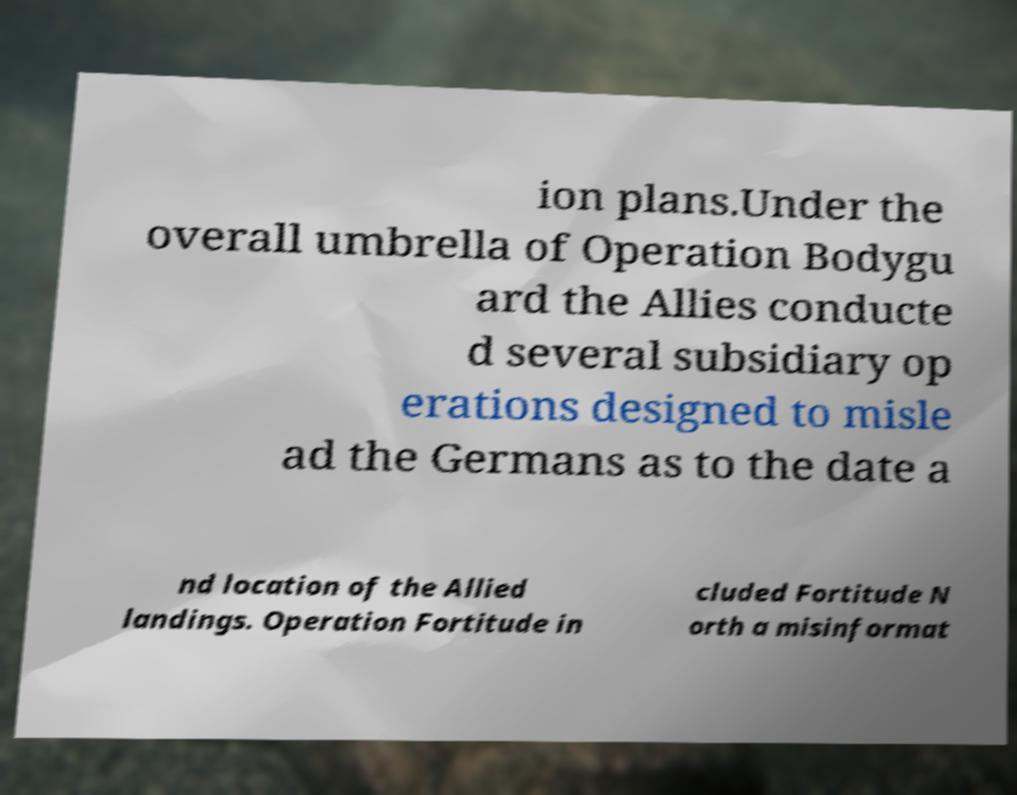Can you accurately transcribe the text from the provided image for me? ion plans.Under the overall umbrella of Operation Bodygu ard the Allies conducte d several subsidiary op erations designed to misle ad the Germans as to the date a nd location of the Allied landings. Operation Fortitude in cluded Fortitude N orth a misinformat 